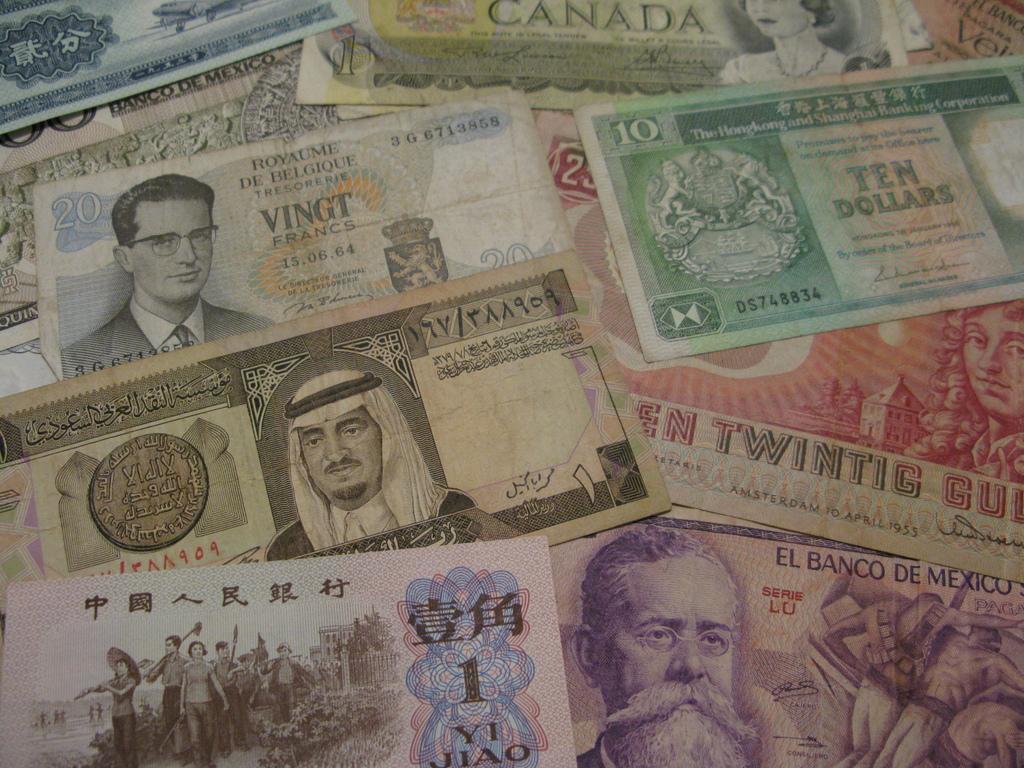Could you give a brief overview of what you see in this image? In this image we can see some currency notes. 